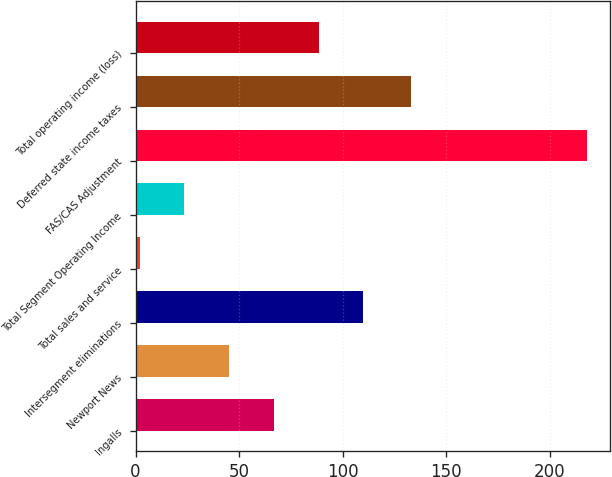<chart> <loc_0><loc_0><loc_500><loc_500><bar_chart><fcel>Ingalls<fcel>Newport News<fcel>Intersegment eliminations<fcel>Total sales and service<fcel>Total Segment Operating Income<fcel>FAS/CAS Adjustment<fcel>Deferred state income taxes<fcel>Total operating income (loss)<nl><fcel>66.8<fcel>45.2<fcel>110<fcel>2<fcel>23.6<fcel>218<fcel>133<fcel>88.4<nl></chart> 